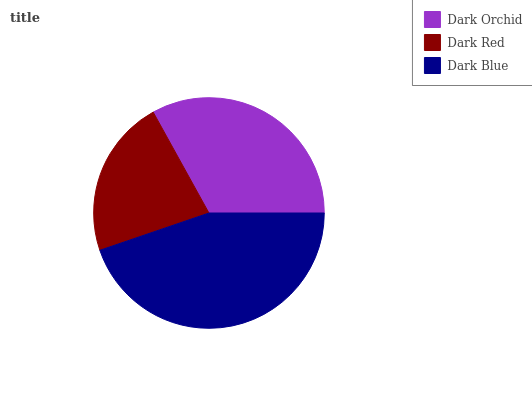Is Dark Red the minimum?
Answer yes or no. Yes. Is Dark Blue the maximum?
Answer yes or no. Yes. Is Dark Blue the minimum?
Answer yes or no. No. Is Dark Red the maximum?
Answer yes or no. No. Is Dark Blue greater than Dark Red?
Answer yes or no. Yes. Is Dark Red less than Dark Blue?
Answer yes or no. Yes. Is Dark Red greater than Dark Blue?
Answer yes or no. No. Is Dark Blue less than Dark Red?
Answer yes or no. No. Is Dark Orchid the high median?
Answer yes or no. Yes. Is Dark Orchid the low median?
Answer yes or no. Yes. Is Dark Blue the high median?
Answer yes or no. No. Is Dark Blue the low median?
Answer yes or no. No. 